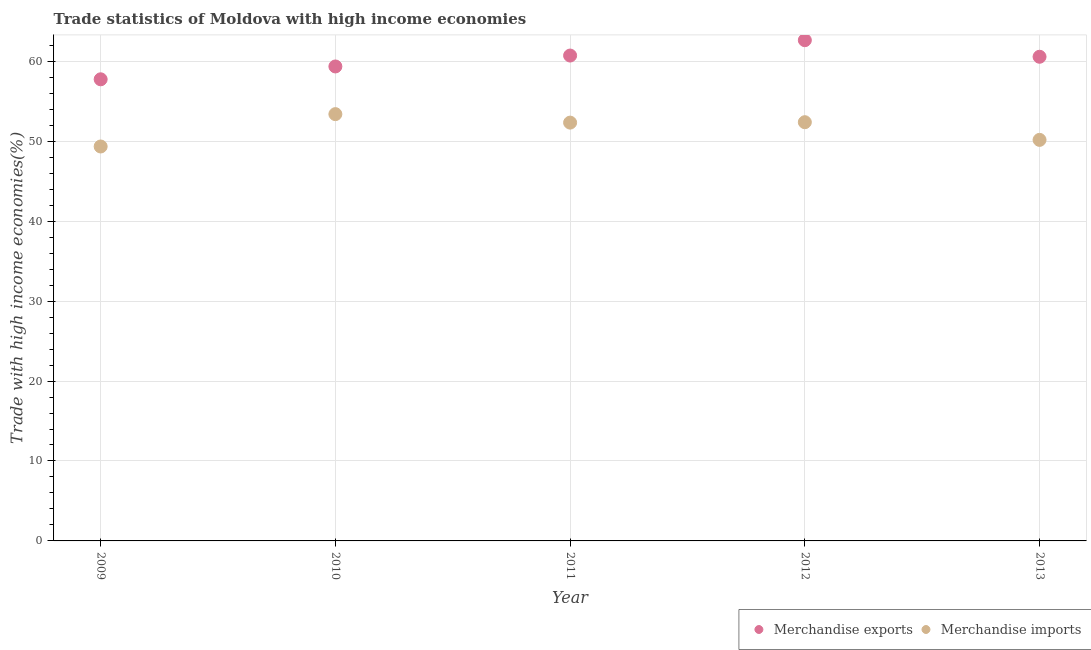Is the number of dotlines equal to the number of legend labels?
Provide a short and direct response. Yes. What is the merchandise imports in 2010?
Provide a short and direct response. 53.39. Across all years, what is the maximum merchandise imports?
Provide a short and direct response. 53.39. Across all years, what is the minimum merchandise exports?
Provide a short and direct response. 57.75. What is the total merchandise imports in the graph?
Offer a terse response. 257.61. What is the difference between the merchandise exports in 2009 and that in 2013?
Give a very brief answer. -2.82. What is the difference between the merchandise imports in 2012 and the merchandise exports in 2013?
Your response must be concise. -8.19. What is the average merchandise imports per year?
Your answer should be compact. 51.52. In the year 2013, what is the difference between the merchandise imports and merchandise exports?
Keep it short and to the point. -10.4. What is the ratio of the merchandise imports in 2012 to that in 2013?
Your answer should be compact. 1.04. Is the difference between the merchandise imports in 2012 and 2013 greater than the difference between the merchandise exports in 2012 and 2013?
Offer a very short reply. Yes. What is the difference between the highest and the second highest merchandise imports?
Ensure brevity in your answer.  1.01. What is the difference between the highest and the lowest merchandise imports?
Offer a terse response. 4.05. In how many years, is the merchandise imports greater than the average merchandise imports taken over all years?
Keep it short and to the point. 3. Is the merchandise imports strictly greater than the merchandise exports over the years?
Ensure brevity in your answer.  No. Is the merchandise exports strictly less than the merchandise imports over the years?
Make the answer very short. No. How many years are there in the graph?
Provide a short and direct response. 5. What is the difference between two consecutive major ticks on the Y-axis?
Your answer should be compact. 10. Does the graph contain any zero values?
Ensure brevity in your answer.  No. Does the graph contain grids?
Offer a terse response. Yes. How are the legend labels stacked?
Your answer should be compact. Horizontal. What is the title of the graph?
Make the answer very short. Trade statistics of Moldova with high income economies. What is the label or title of the Y-axis?
Offer a terse response. Trade with high income economies(%). What is the Trade with high income economies(%) of Merchandise exports in 2009?
Your answer should be compact. 57.75. What is the Trade with high income economies(%) in Merchandise imports in 2009?
Your answer should be compact. 49.34. What is the Trade with high income economies(%) of Merchandise exports in 2010?
Offer a terse response. 59.35. What is the Trade with high income economies(%) of Merchandise imports in 2010?
Offer a terse response. 53.39. What is the Trade with high income economies(%) in Merchandise exports in 2011?
Ensure brevity in your answer.  60.72. What is the Trade with high income economies(%) of Merchandise imports in 2011?
Provide a succinct answer. 52.33. What is the Trade with high income economies(%) in Merchandise exports in 2012?
Your answer should be compact. 62.64. What is the Trade with high income economies(%) of Merchandise imports in 2012?
Offer a very short reply. 52.38. What is the Trade with high income economies(%) in Merchandise exports in 2013?
Ensure brevity in your answer.  60.57. What is the Trade with high income economies(%) of Merchandise imports in 2013?
Provide a succinct answer. 50.17. Across all years, what is the maximum Trade with high income economies(%) in Merchandise exports?
Make the answer very short. 62.64. Across all years, what is the maximum Trade with high income economies(%) in Merchandise imports?
Your answer should be compact. 53.39. Across all years, what is the minimum Trade with high income economies(%) in Merchandise exports?
Provide a short and direct response. 57.75. Across all years, what is the minimum Trade with high income economies(%) of Merchandise imports?
Keep it short and to the point. 49.34. What is the total Trade with high income economies(%) in Merchandise exports in the graph?
Your answer should be compact. 301.03. What is the total Trade with high income economies(%) of Merchandise imports in the graph?
Provide a short and direct response. 257.61. What is the difference between the Trade with high income economies(%) in Merchandise exports in 2009 and that in 2010?
Offer a very short reply. -1.61. What is the difference between the Trade with high income economies(%) in Merchandise imports in 2009 and that in 2010?
Offer a very short reply. -4.05. What is the difference between the Trade with high income economies(%) of Merchandise exports in 2009 and that in 2011?
Your answer should be very brief. -2.97. What is the difference between the Trade with high income economies(%) in Merchandise imports in 2009 and that in 2011?
Your answer should be compact. -2.99. What is the difference between the Trade with high income economies(%) of Merchandise exports in 2009 and that in 2012?
Keep it short and to the point. -4.89. What is the difference between the Trade with high income economies(%) of Merchandise imports in 2009 and that in 2012?
Your response must be concise. -3.04. What is the difference between the Trade with high income economies(%) of Merchandise exports in 2009 and that in 2013?
Your answer should be very brief. -2.82. What is the difference between the Trade with high income economies(%) of Merchandise imports in 2009 and that in 2013?
Ensure brevity in your answer.  -0.83. What is the difference between the Trade with high income economies(%) of Merchandise exports in 2010 and that in 2011?
Give a very brief answer. -1.36. What is the difference between the Trade with high income economies(%) in Merchandise imports in 2010 and that in 2011?
Your answer should be compact. 1.06. What is the difference between the Trade with high income economies(%) in Merchandise exports in 2010 and that in 2012?
Your answer should be compact. -3.29. What is the difference between the Trade with high income economies(%) in Merchandise imports in 2010 and that in 2012?
Your response must be concise. 1.01. What is the difference between the Trade with high income economies(%) in Merchandise exports in 2010 and that in 2013?
Offer a terse response. -1.21. What is the difference between the Trade with high income economies(%) of Merchandise imports in 2010 and that in 2013?
Offer a terse response. 3.22. What is the difference between the Trade with high income economies(%) of Merchandise exports in 2011 and that in 2012?
Ensure brevity in your answer.  -1.92. What is the difference between the Trade with high income economies(%) of Merchandise imports in 2011 and that in 2012?
Offer a terse response. -0.05. What is the difference between the Trade with high income economies(%) of Merchandise exports in 2011 and that in 2013?
Your answer should be very brief. 0.15. What is the difference between the Trade with high income economies(%) of Merchandise imports in 2011 and that in 2013?
Give a very brief answer. 2.16. What is the difference between the Trade with high income economies(%) of Merchandise exports in 2012 and that in 2013?
Your answer should be compact. 2.07. What is the difference between the Trade with high income economies(%) of Merchandise imports in 2012 and that in 2013?
Your answer should be very brief. 2.21. What is the difference between the Trade with high income economies(%) in Merchandise exports in 2009 and the Trade with high income economies(%) in Merchandise imports in 2010?
Provide a succinct answer. 4.36. What is the difference between the Trade with high income economies(%) in Merchandise exports in 2009 and the Trade with high income economies(%) in Merchandise imports in 2011?
Make the answer very short. 5.42. What is the difference between the Trade with high income economies(%) of Merchandise exports in 2009 and the Trade with high income economies(%) of Merchandise imports in 2012?
Provide a succinct answer. 5.37. What is the difference between the Trade with high income economies(%) of Merchandise exports in 2009 and the Trade with high income economies(%) of Merchandise imports in 2013?
Offer a terse response. 7.58. What is the difference between the Trade with high income economies(%) in Merchandise exports in 2010 and the Trade with high income economies(%) in Merchandise imports in 2011?
Provide a succinct answer. 7.03. What is the difference between the Trade with high income economies(%) in Merchandise exports in 2010 and the Trade with high income economies(%) in Merchandise imports in 2012?
Offer a terse response. 6.97. What is the difference between the Trade with high income economies(%) of Merchandise exports in 2010 and the Trade with high income economies(%) of Merchandise imports in 2013?
Make the answer very short. 9.18. What is the difference between the Trade with high income economies(%) in Merchandise exports in 2011 and the Trade with high income economies(%) in Merchandise imports in 2012?
Make the answer very short. 8.34. What is the difference between the Trade with high income economies(%) of Merchandise exports in 2011 and the Trade with high income economies(%) of Merchandise imports in 2013?
Make the answer very short. 10.55. What is the difference between the Trade with high income economies(%) of Merchandise exports in 2012 and the Trade with high income economies(%) of Merchandise imports in 2013?
Your answer should be very brief. 12.47. What is the average Trade with high income economies(%) of Merchandise exports per year?
Provide a short and direct response. 60.21. What is the average Trade with high income economies(%) in Merchandise imports per year?
Your answer should be very brief. 51.52. In the year 2009, what is the difference between the Trade with high income economies(%) of Merchandise exports and Trade with high income economies(%) of Merchandise imports?
Offer a terse response. 8.41. In the year 2010, what is the difference between the Trade with high income economies(%) of Merchandise exports and Trade with high income economies(%) of Merchandise imports?
Provide a short and direct response. 5.96. In the year 2011, what is the difference between the Trade with high income economies(%) of Merchandise exports and Trade with high income economies(%) of Merchandise imports?
Provide a short and direct response. 8.39. In the year 2012, what is the difference between the Trade with high income economies(%) in Merchandise exports and Trade with high income economies(%) in Merchandise imports?
Your response must be concise. 10.26. In the year 2013, what is the difference between the Trade with high income economies(%) of Merchandise exports and Trade with high income economies(%) of Merchandise imports?
Offer a terse response. 10.4. What is the ratio of the Trade with high income economies(%) of Merchandise exports in 2009 to that in 2010?
Make the answer very short. 0.97. What is the ratio of the Trade with high income economies(%) of Merchandise imports in 2009 to that in 2010?
Provide a succinct answer. 0.92. What is the ratio of the Trade with high income economies(%) in Merchandise exports in 2009 to that in 2011?
Your answer should be very brief. 0.95. What is the ratio of the Trade with high income economies(%) in Merchandise imports in 2009 to that in 2011?
Ensure brevity in your answer.  0.94. What is the ratio of the Trade with high income economies(%) in Merchandise exports in 2009 to that in 2012?
Offer a very short reply. 0.92. What is the ratio of the Trade with high income economies(%) of Merchandise imports in 2009 to that in 2012?
Provide a succinct answer. 0.94. What is the ratio of the Trade with high income economies(%) in Merchandise exports in 2009 to that in 2013?
Keep it short and to the point. 0.95. What is the ratio of the Trade with high income economies(%) of Merchandise imports in 2009 to that in 2013?
Make the answer very short. 0.98. What is the ratio of the Trade with high income economies(%) of Merchandise exports in 2010 to that in 2011?
Give a very brief answer. 0.98. What is the ratio of the Trade with high income economies(%) in Merchandise imports in 2010 to that in 2011?
Provide a short and direct response. 1.02. What is the ratio of the Trade with high income economies(%) of Merchandise exports in 2010 to that in 2012?
Provide a short and direct response. 0.95. What is the ratio of the Trade with high income economies(%) of Merchandise imports in 2010 to that in 2012?
Provide a short and direct response. 1.02. What is the ratio of the Trade with high income economies(%) in Merchandise exports in 2010 to that in 2013?
Give a very brief answer. 0.98. What is the ratio of the Trade with high income economies(%) of Merchandise imports in 2010 to that in 2013?
Your answer should be very brief. 1.06. What is the ratio of the Trade with high income economies(%) of Merchandise exports in 2011 to that in 2012?
Ensure brevity in your answer.  0.97. What is the ratio of the Trade with high income economies(%) in Merchandise imports in 2011 to that in 2012?
Your response must be concise. 1. What is the ratio of the Trade with high income economies(%) in Merchandise imports in 2011 to that in 2013?
Make the answer very short. 1.04. What is the ratio of the Trade with high income economies(%) of Merchandise exports in 2012 to that in 2013?
Your response must be concise. 1.03. What is the ratio of the Trade with high income economies(%) in Merchandise imports in 2012 to that in 2013?
Your answer should be compact. 1.04. What is the difference between the highest and the second highest Trade with high income economies(%) in Merchandise exports?
Make the answer very short. 1.92. What is the difference between the highest and the second highest Trade with high income economies(%) in Merchandise imports?
Ensure brevity in your answer.  1.01. What is the difference between the highest and the lowest Trade with high income economies(%) in Merchandise exports?
Offer a terse response. 4.89. What is the difference between the highest and the lowest Trade with high income economies(%) in Merchandise imports?
Keep it short and to the point. 4.05. 